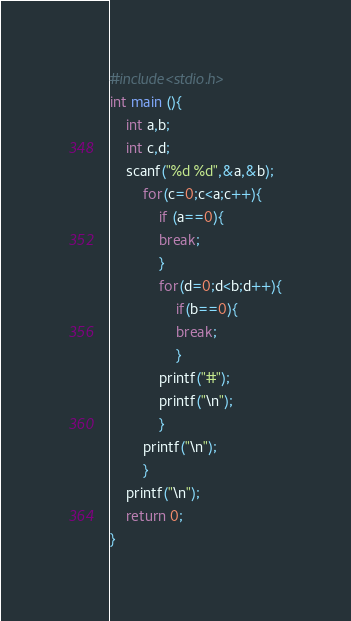Convert code to text. <code><loc_0><loc_0><loc_500><loc_500><_C_>#include<stdio.h>
int main (){
	int a,b;
	int c,d;
	scanf("%d %d",&a,&b);
		for(c=0;c<a;c++){
			if (a==0){
			break;
			}
			for(d=0;d<b;d++){
				if(b==0){
				break;
				}
			printf("#");
			printf("\n");
			}
		printf("\n");
		}
	printf("\n");
	return 0;
}</code> 